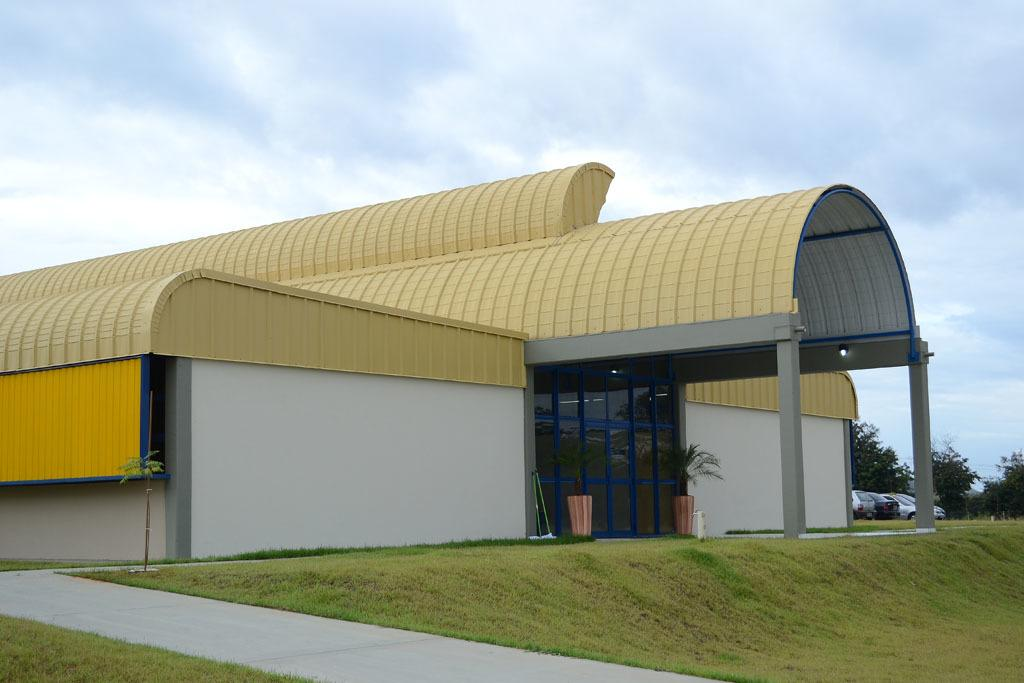Where was the image taken? The image was clicked outside. What is located in the middle of the image? There is a stool in the middle of the image. What type of vegetation can be seen in the image? There are plants and trees in the image. What can be seen on the right side of the image? There are cars on the right side of the image. What is visible at the top of the image? The sky is visible at the top of the image. What type of cheese is being used to build the nerve in the image? There is no cheese or nerve present in the image; it features a stool, plants, trees, cars, and the sky. 